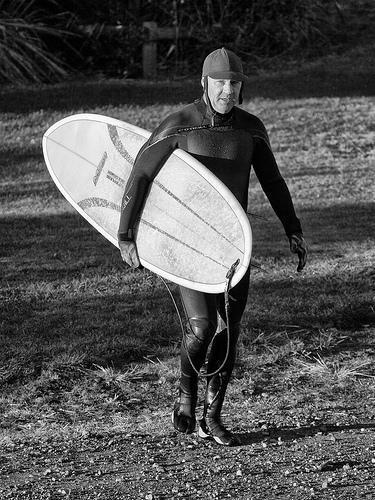How many surfboards are shown in the photo?
Give a very brief answer. 1. 